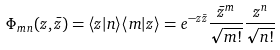<formula> <loc_0><loc_0><loc_500><loc_500>\Phi _ { m n } ( z , \bar { z } ) = \langle z | n \rangle \langle m | z \rangle = e ^ { - z \bar { z } } \frac { { \bar { z } } ^ { m } } { \sqrt { m ! } } \frac { z ^ { n } } { \sqrt { n ! } }</formula> 